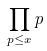Convert formula to latex. <formula><loc_0><loc_0><loc_500><loc_500>\prod _ { p \leq x } p</formula> 